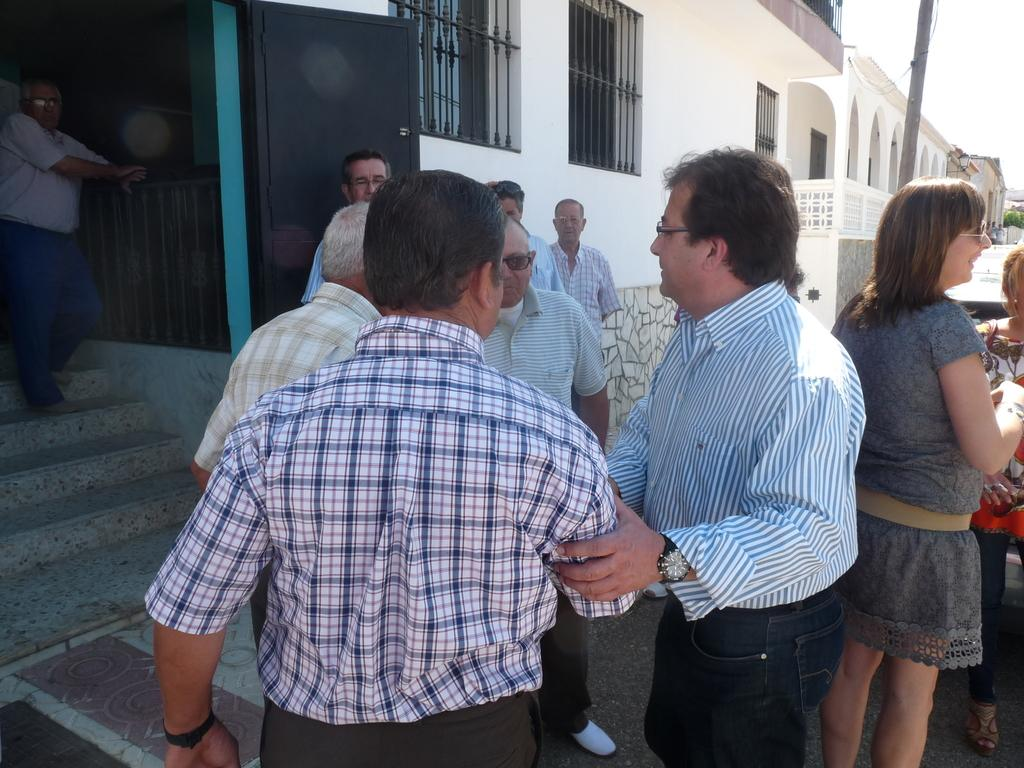What are the people in the image doing? The people in the image are standing on a road. What can be seen in the background of the image? There are buildings in the background of the image. How many toes can be seen on the mountain in the image? A: There is no mountain present in the image, and therefore no toes can be seen on it. 